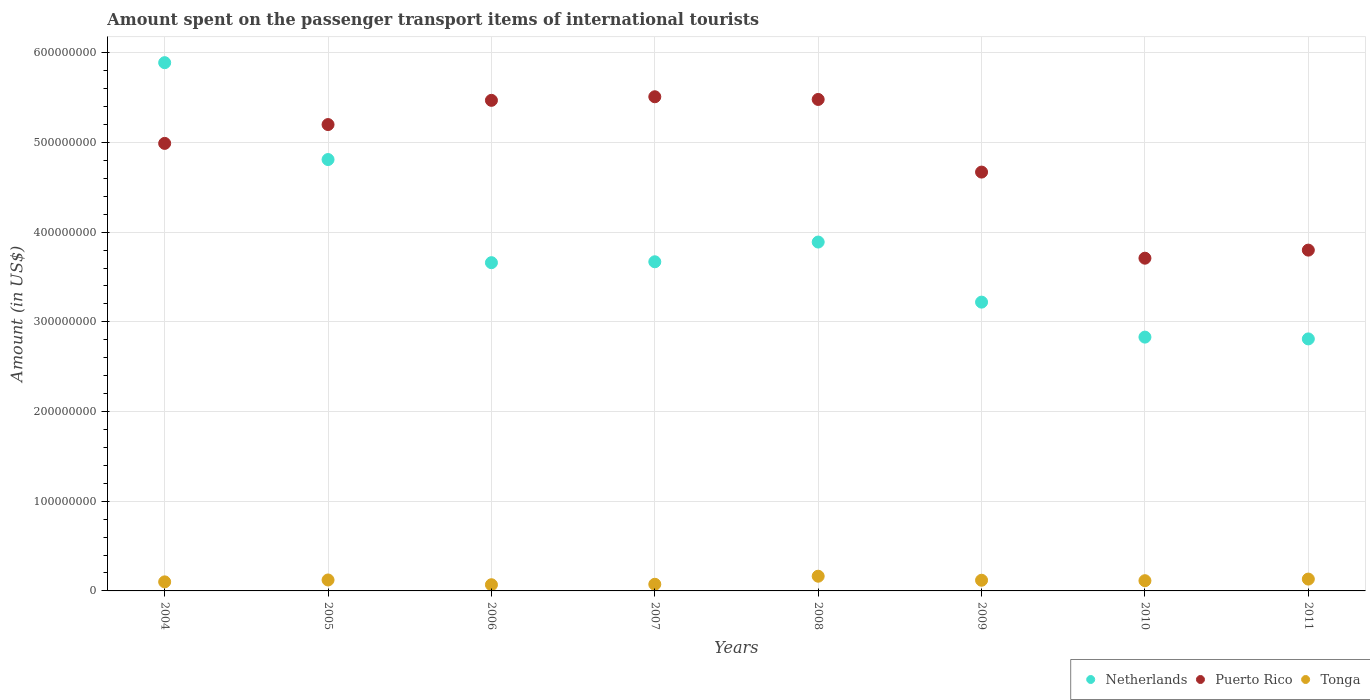How many different coloured dotlines are there?
Ensure brevity in your answer.  3. What is the amount spent on the passenger transport items of international tourists in Tonga in 2005?
Your answer should be compact. 1.22e+07. Across all years, what is the maximum amount spent on the passenger transport items of international tourists in Netherlands?
Make the answer very short. 5.89e+08. Across all years, what is the minimum amount spent on the passenger transport items of international tourists in Netherlands?
Keep it short and to the point. 2.81e+08. What is the total amount spent on the passenger transport items of international tourists in Puerto Rico in the graph?
Give a very brief answer. 3.88e+09. What is the difference between the amount spent on the passenger transport items of international tourists in Netherlands in 2004 and that in 2007?
Offer a very short reply. 2.22e+08. What is the difference between the amount spent on the passenger transport items of international tourists in Netherlands in 2005 and the amount spent on the passenger transport items of international tourists in Puerto Rico in 2010?
Give a very brief answer. 1.10e+08. What is the average amount spent on the passenger transport items of international tourists in Netherlands per year?
Keep it short and to the point. 3.85e+08. In the year 2008, what is the difference between the amount spent on the passenger transport items of international tourists in Puerto Rico and amount spent on the passenger transport items of international tourists in Netherlands?
Provide a short and direct response. 1.59e+08. What is the ratio of the amount spent on the passenger transport items of international tourists in Tonga in 2007 to that in 2009?
Offer a terse response. 0.62. Is the amount spent on the passenger transport items of international tourists in Puerto Rico in 2005 less than that in 2006?
Offer a very short reply. Yes. What is the difference between the highest and the second highest amount spent on the passenger transport items of international tourists in Tonga?
Provide a short and direct response. 3.20e+06. What is the difference between the highest and the lowest amount spent on the passenger transport items of international tourists in Puerto Rico?
Offer a terse response. 1.80e+08. In how many years, is the amount spent on the passenger transport items of international tourists in Tonga greater than the average amount spent on the passenger transport items of international tourists in Tonga taken over all years?
Offer a terse response. 5. Is it the case that in every year, the sum of the amount spent on the passenger transport items of international tourists in Tonga and amount spent on the passenger transport items of international tourists in Netherlands  is greater than the amount spent on the passenger transport items of international tourists in Puerto Rico?
Your answer should be very brief. No. How many dotlines are there?
Offer a terse response. 3. How many years are there in the graph?
Ensure brevity in your answer.  8. What is the difference between two consecutive major ticks on the Y-axis?
Provide a short and direct response. 1.00e+08. Does the graph contain any zero values?
Your answer should be compact. No. Does the graph contain grids?
Your answer should be compact. Yes. Where does the legend appear in the graph?
Keep it short and to the point. Bottom right. How are the legend labels stacked?
Make the answer very short. Horizontal. What is the title of the graph?
Give a very brief answer. Amount spent on the passenger transport items of international tourists. Does "Chad" appear as one of the legend labels in the graph?
Your answer should be compact. No. What is the Amount (in US$) in Netherlands in 2004?
Make the answer very short. 5.89e+08. What is the Amount (in US$) of Puerto Rico in 2004?
Provide a short and direct response. 4.99e+08. What is the Amount (in US$) in Tonga in 2004?
Your answer should be very brief. 1.01e+07. What is the Amount (in US$) in Netherlands in 2005?
Your response must be concise. 4.81e+08. What is the Amount (in US$) of Puerto Rico in 2005?
Provide a succinct answer. 5.20e+08. What is the Amount (in US$) of Tonga in 2005?
Give a very brief answer. 1.22e+07. What is the Amount (in US$) in Netherlands in 2006?
Ensure brevity in your answer.  3.66e+08. What is the Amount (in US$) of Puerto Rico in 2006?
Keep it short and to the point. 5.47e+08. What is the Amount (in US$) in Tonga in 2006?
Give a very brief answer. 6.90e+06. What is the Amount (in US$) in Netherlands in 2007?
Ensure brevity in your answer.  3.67e+08. What is the Amount (in US$) of Puerto Rico in 2007?
Keep it short and to the point. 5.51e+08. What is the Amount (in US$) in Tonga in 2007?
Offer a terse response. 7.40e+06. What is the Amount (in US$) in Netherlands in 2008?
Provide a succinct answer. 3.89e+08. What is the Amount (in US$) in Puerto Rico in 2008?
Keep it short and to the point. 5.48e+08. What is the Amount (in US$) of Tonga in 2008?
Offer a terse response. 1.64e+07. What is the Amount (in US$) of Netherlands in 2009?
Make the answer very short. 3.22e+08. What is the Amount (in US$) in Puerto Rico in 2009?
Your answer should be compact. 4.67e+08. What is the Amount (in US$) in Tonga in 2009?
Keep it short and to the point. 1.19e+07. What is the Amount (in US$) in Netherlands in 2010?
Your response must be concise. 2.83e+08. What is the Amount (in US$) of Puerto Rico in 2010?
Give a very brief answer. 3.71e+08. What is the Amount (in US$) of Tonga in 2010?
Keep it short and to the point. 1.14e+07. What is the Amount (in US$) of Netherlands in 2011?
Your response must be concise. 2.81e+08. What is the Amount (in US$) in Puerto Rico in 2011?
Your answer should be compact. 3.80e+08. What is the Amount (in US$) in Tonga in 2011?
Your answer should be compact. 1.32e+07. Across all years, what is the maximum Amount (in US$) in Netherlands?
Your answer should be compact. 5.89e+08. Across all years, what is the maximum Amount (in US$) in Puerto Rico?
Make the answer very short. 5.51e+08. Across all years, what is the maximum Amount (in US$) in Tonga?
Ensure brevity in your answer.  1.64e+07. Across all years, what is the minimum Amount (in US$) in Netherlands?
Your answer should be very brief. 2.81e+08. Across all years, what is the minimum Amount (in US$) in Puerto Rico?
Provide a short and direct response. 3.71e+08. Across all years, what is the minimum Amount (in US$) of Tonga?
Provide a short and direct response. 6.90e+06. What is the total Amount (in US$) of Netherlands in the graph?
Offer a terse response. 3.08e+09. What is the total Amount (in US$) of Puerto Rico in the graph?
Provide a short and direct response. 3.88e+09. What is the total Amount (in US$) of Tonga in the graph?
Provide a succinct answer. 8.95e+07. What is the difference between the Amount (in US$) in Netherlands in 2004 and that in 2005?
Give a very brief answer. 1.08e+08. What is the difference between the Amount (in US$) in Puerto Rico in 2004 and that in 2005?
Your answer should be very brief. -2.10e+07. What is the difference between the Amount (in US$) of Tonga in 2004 and that in 2005?
Your response must be concise. -2.10e+06. What is the difference between the Amount (in US$) in Netherlands in 2004 and that in 2006?
Make the answer very short. 2.23e+08. What is the difference between the Amount (in US$) in Puerto Rico in 2004 and that in 2006?
Ensure brevity in your answer.  -4.80e+07. What is the difference between the Amount (in US$) in Tonga in 2004 and that in 2006?
Make the answer very short. 3.20e+06. What is the difference between the Amount (in US$) of Netherlands in 2004 and that in 2007?
Ensure brevity in your answer.  2.22e+08. What is the difference between the Amount (in US$) of Puerto Rico in 2004 and that in 2007?
Provide a short and direct response. -5.20e+07. What is the difference between the Amount (in US$) of Tonga in 2004 and that in 2007?
Make the answer very short. 2.70e+06. What is the difference between the Amount (in US$) in Puerto Rico in 2004 and that in 2008?
Provide a short and direct response. -4.90e+07. What is the difference between the Amount (in US$) of Tonga in 2004 and that in 2008?
Give a very brief answer. -6.30e+06. What is the difference between the Amount (in US$) in Netherlands in 2004 and that in 2009?
Offer a terse response. 2.67e+08. What is the difference between the Amount (in US$) of Puerto Rico in 2004 and that in 2009?
Offer a terse response. 3.20e+07. What is the difference between the Amount (in US$) of Tonga in 2004 and that in 2009?
Keep it short and to the point. -1.80e+06. What is the difference between the Amount (in US$) of Netherlands in 2004 and that in 2010?
Your answer should be compact. 3.06e+08. What is the difference between the Amount (in US$) of Puerto Rico in 2004 and that in 2010?
Ensure brevity in your answer.  1.28e+08. What is the difference between the Amount (in US$) of Tonga in 2004 and that in 2010?
Give a very brief answer. -1.30e+06. What is the difference between the Amount (in US$) of Netherlands in 2004 and that in 2011?
Your response must be concise. 3.08e+08. What is the difference between the Amount (in US$) of Puerto Rico in 2004 and that in 2011?
Offer a very short reply. 1.19e+08. What is the difference between the Amount (in US$) of Tonga in 2004 and that in 2011?
Your answer should be very brief. -3.10e+06. What is the difference between the Amount (in US$) in Netherlands in 2005 and that in 2006?
Provide a succinct answer. 1.15e+08. What is the difference between the Amount (in US$) of Puerto Rico in 2005 and that in 2006?
Give a very brief answer. -2.70e+07. What is the difference between the Amount (in US$) of Tonga in 2005 and that in 2006?
Your answer should be compact. 5.30e+06. What is the difference between the Amount (in US$) in Netherlands in 2005 and that in 2007?
Your response must be concise. 1.14e+08. What is the difference between the Amount (in US$) of Puerto Rico in 2005 and that in 2007?
Keep it short and to the point. -3.10e+07. What is the difference between the Amount (in US$) in Tonga in 2005 and that in 2007?
Provide a succinct answer. 4.80e+06. What is the difference between the Amount (in US$) of Netherlands in 2005 and that in 2008?
Make the answer very short. 9.20e+07. What is the difference between the Amount (in US$) in Puerto Rico in 2005 and that in 2008?
Your answer should be compact. -2.80e+07. What is the difference between the Amount (in US$) in Tonga in 2005 and that in 2008?
Offer a very short reply. -4.20e+06. What is the difference between the Amount (in US$) of Netherlands in 2005 and that in 2009?
Give a very brief answer. 1.59e+08. What is the difference between the Amount (in US$) in Puerto Rico in 2005 and that in 2009?
Give a very brief answer. 5.30e+07. What is the difference between the Amount (in US$) in Tonga in 2005 and that in 2009?
Keep it short and to the point. 3.00e+05. What is the difference between the Amount (in US$) in Netherlands in 2005 and that in 2010?
Your response must be concise. 1.98e+08. What is the difference between the Amount (in US$) of Puerto Rico in 2005 and that in 2010?
Give a very brief answer. 1.49e+08. What is the difference between the Amount (in US$) in Tonga in 2005 and that in 2010?
Provide a short and direct response. 8.00e+05. What is the difference between the Amount (in US$) of Puerto Rico in 2005 and that in 2011?
Give a very brief answer. 1.40e+08. What is the difference between the Amount (in US$) of Netherlands in 2006 and that in 2007?
Provide a short and direct response. -1.00e+06. What is the difference between the Amount (in US$) in Puerto Rico in 2006 and that in 2007?
Your response must be concise. -4.00e+06. What is the difference between the Amount (in US$) in Tonga in 2006 and that in 2007?
Your answer should be very brief. -5.00e+05. What is the difference between the Amount (in US$) in Netherlands in 2006 and that in 2008?
Your answer should be very brief. -2.30e+07. What is the difference between the Amount (in US$) in Puerto Rico in 2006 and that in 2008?
Offer a terse response. -1.00e+06. What is the difference between the Amount (in US$) in Tonga in 2006 and that in 2008?
Give a very brief answer. -9.50e+06. What is the difference between the Amount (in US$) of Netherlands in 2006 and that in 2009?
Offer a very short reply. 4.40e+07. What is the difference between the Amount (in US$) of Puerto Rico in 2006 and that in 2009?
Make the answer very short. 8.00e+07. What is the difference between the Amount (in US$) in Tonga in 2006 and that in 2009?
Provide a short and direct response. -5.00e+06. What is the difference between the Amount (in US$) of Netherlands in 2006 and that in 2010?
Keep it short and to the point. 8.30e+07. What is the difference between the Amount (in US$) of Puerto Rico in 2006 and that in 2010?
Offer a very short reply. 1.76e+08. What is the difference between the Amount (in US$) of Tonga in 2006 and that in 2010?
Your answer should be compact. -4.50e+06. What is the difference between the Amount (in US$) of Netherlands in 2006 and that in 2011?
Your answer should be compact. 8.50e+07. What is the difference between the Amount (in US$) of Puerto Rico in 2006 and that in 2011?
Offer a very short reply. 1.67e+08. What is the difference between the Amount (in US$) of Tonga in 2006 and that in 2011?
Ensure brevity in your answer.  -6.30e+06. What is the difference between the Amount (in US$) in Netherlands in 2007 and that in 2008?
Provide a succinct answer. -2.20e+07. What is the difference between the Amount (in US$) in Puerto Rico in 2007 and that in 2008?
Your answer should be very brief. 3.00e+06. What is the difference between the Amount (in US$) of Tonga in 2007 and that in 2008?
Make the answer very short. -9.00e+06. What is the difference between the Amount (in US$) of Netherlands in 2007 and that in 2009?
Give a very brief answer. 4.50e+07. What is the difference between the Amount (in US$) of Puerto Rico in 2007 and that in 2009?
Offer a very short reply. 8.40e+07. What is the difference between the Amount (in US$) in Tonga in 2007 and that in 2009?
Keep it short and to the point. -4.50e+06. What is the difference between the Amount (in US$) of Netherlands in 2007 and that in 2010?
Give a very brief answer. 8.40e+07. What is the difference between the Amount (in US$) in Puerto Rico in 2007 and that in 2010?
Your answer should be very brief. 1.80e+08. What is the difference between the Amount (in US$) in Netherlands in 2007 and that in 2011?
Offer a very short reply. 8.60e+07. What is the difference between the Amount (in US$) in Puerto Rico in 2007 and that in 2011?
Your response must be concise. 1.71e+08. What is the difference between the Amount (in US$) of Tonga in 2007 and that in 2011?
Offer a very short reply. -5.80e+06. What is the difference between the Amount (in US$) of Netherlands in 2008 and that in 2009?
Provide a succinct answer. 6.70e+07. What is the difference between the Amount (in US$) of Puerto Rico in 2008 and that in 2009?
Your answer should be very brief. 8.10e+07. What is the difference between the Amount (in US$) in Tonga in 2008 and that in 2009?
Give a very brief answer. 4.50e+06. What is the difference between the Amount (in US$) of Netherlands in 2008 and that in 2010?
Provide a short and direct response. 1.06e+08. What is the difference between the Amount (in US$) of Puerto Rico in 2008 and that in 2010?
Your answer should be compact. 1.77e+08. What is the difference between the Amount (in US$) of Netherlands in 2008 and that in 2011?
Keep it short and to the point. 1.08e+08. What is the difference between the Amount (in US$) of Puerto Rico in 2008 and that in 2011?
Your answer should be compact. 1.68e+08. What is the difference between the Amount (in US$) in Tonga in 2008 and that in 2011?
Offer a terse response. 3.20e+06. What is the difference between the Amount (in US$) of Netherlands in 2009 and that in 2010?
Make the answer very short. 3.90e+07. What is the difference between the Amount (in US$) in Puerto Rico in 2009 and that in 2010?
Provide a succinct answer. 9.60e+07. What is the difference between the Amount (in US$) in Netherlands in 2009 and that in 2011?
Provide a short and direct response. 4.10e+07. What is the difference between the Amount (in US$) of Puerto Rico in 2009 and that in 2011?
Your answer should be compact. 8.70e+07. What is the difference between the Amount (in US$) in Tonga in 2009 and that in 2011?
Your response must be concise. -1.30e+06. What is the difference between the Amount (in US$) of Puerto Rico in 2010 and that in 2011?
Offer a very short reply. -9.00e+06. What is the difference between the Amount (in US$) of Tonga in 2010 and that in 2011?
Provide a short and direct response. -1.80e+06. What is the difference between the Amount (in US$) of Netherlands in 2004 and the Amount (in US$) of Puerto Rico in 2005?
Offer a very short reply. 6.90e+07. What is the difference between the Amount (in US$) in Netherlands in 2004 and the Amount (in US$) in Tonga in 2005?
Your response must be concise. 5.77e+08. What is the difference between the Amount (in US$) in Puerto Rico in 2004 and the Amount (in US$) in Tonga in 2005?
Ensure brevity in your answer.  4.87e+08. What is the difference between the Amount (in US$) of Netherlands in 2004 and the Amount (in US$) of Puerto Rico in 2006?
Your answer should be very brief. 4.20e+07. What is the difference between the Amount (in US$) in Netherlands in 2004 and the Amount (in US$) in Tonga in 2006?
Your answer should be compact. 5.82e+08. What is the difference between the Amount (in US$) of Puerto Rico in 2004 and the Amount (in US$) of Tonga in 2006?
Give a very brief answer. 4.92e+08. What is the difference between the Amount (in US$) in Netherlands in 2004 and the Amount (in US$) in Puerto Rico in 2007?
Offer a terse response. 3.80e+07. What is the difference between the Amount (in US$) in Netherlands in 2004 and the Amount (in US$) in Tonga in 2007?
Your response must be concise. 5.82e+08. What is the difference between the Amount (in US$) of Puerto Rico in 2004 and the Amount (in US$) of Tonga in 2007?
Provide a short and direct response. 4.92e+08. What is the difference between the Amount (in US$) of Netherlands in 2004 and the Amount (in US$) of Puerto Rico in 2008?
Keep it short and to the point. 4.10e+07. What is the difference between the Amount (in US$) of Netherlands in 2004 and the Amount (in US$) of Tonga in 2008?
Your response must be concise. 5.73e+08. What is the difference between the Amount (in US$) of Puerto Rico in 2004 and the Amount (in US$) of Tonga in 2008?
Provide a succinct answer. 4.83e+08. What is the difference between the Amount (in US$) in Netherlands in 2004 and the Amount (in US$) in Puerto Rico in 2009?
Keep it short and to the point. 1.22e+08. What is the difference between the Amount (in US$) in Netherlands in 2004 and the Amount (in US$) in Tonga in 2009?
Your answer should be very brief. 5.77e+08. What is the difference between the Amount (in US$) in Puerto Rico in 2004 and the Amount (in US$) in Tonga in 2009?
Keep it short and to the point. 4.87e+08. What is the difference between the Amount (in US$) in Netherlands in 2004 and the Amount (in US$) in Puerto Rico in 2010?
Give a very brief answer. 2.18e+08. What is the difference between the Amount (in US$) of Netherlands in 2004 and the Amount (in US$) of Tonga in 2010?
Your answer should be compact. 5.78e+08. What is the difference between the Amount (in US$) in Puerto Rico in 2004 and the Amount (in US$) in Tonga in 2010?
Offer a terse response. 4.88e+08. What is the difference between the Amount (in US$) of Netherlands in 2004 and the Amount (in US$) of Puerto Rico in 2011?
Give a very brief answer. 2.09e+08. What is the difference between the Amount (in US$) of Netherlands in 2004 and the Amount (in US$) of Tonga in 2011?
Provide a succinct answer. 5.76e+08. What is the difference between the Amount (in US$) in Puerto Rico in 2004 and the Amount (in US$) in Tonga in 2011?
Offer a very short reply. 4.86e+08. What is the difference between the Amount (in US$) of Netherlands in 2005 and the Amount (in US$) of Puerto Rico in 2006?
Keep it short and to the point. -6.60e+07. What is the difference between the Amount (in US$) of Netherlands in 2005 and the Amount (in US$) of Tonga in 2006?
Provide a succinct answer. 4.74e+08. What is the difference between the Amount (in US$) in Puerto Rico in 2005 and the Amount (in US$) in Tonga in 2006?
Provide a succinct answer. 5.13e+08. What is the difference between the Amount (in US$) of Netherlands in 2005 and the Amount (in US$) of Puerto Rico in 2007?
Provide a short and direct response. -7.00e+07. What is the difference between the Amount (in US$) of Netherlands in 2005 and the Amount (in US$) of Tonga in 2007?
Give a very brief answer. 4.74e+08. What is the difference between the Amount (in US$) in Puerto Rico in 2005 and the Amount (in US$) in Tonga in 2007?
Give a very brief answer. 5.13e+08. What is the difference between the Amount (in US$) of Netherlands in 2005 and the Amount (in US$) of Puerto Rico in 2008?
Make the answer very short. -6.70e+07. What is the difference between the Amount (in US$) in Netherlands in 2005 and the Amount (in US$) in Tonga in 2008?
Your answer should be very brief. 4.65e+08. What is the difference between the Amount (in US$) in Puerto Rico in 2005 and the Amount (in US$) in Tonga in 2008?
Give a very brief answer. 5.04e+08. What is the difference between the Amount (in US$) in Netherlands in 2005 and the Amount (in US$) in Puerto Rico in 2009?
Make the answer very short. 1.40e+07. What is the difference between the Amount (in US$) in Netherlands in 2005 and the Amount (in US$) in Tonga in 2009?
Your response must be concise. 4.69e+08. What is the difference between the Amount (in US$) of Puerto Rico in 2005 and the Amount (in US$) of Tonga in 2009?
Your response must be concise. 5.08e+08. What is the difference between the Amount (in US$) in Netherlands in 2005 and the Amount (in US$) in Puerto Rico in 2010?
Ensure brevity in your answer.  1.10e+08. What is the difference between the Amount (in US$) of Netherlands in 2005 and the Amount (in US$) of Tonga in 2010?
Offer a very short reply. 4.70e+08. What is the difference between the Amount (in US$) of Puerto Rico in 2005 and the Amount (in US$) of Tonga in 2010?
Keep it short and to the point. 5.09e+08. What is the difference between the Amount (in US$) of Netherlands in 2005 and the Amount (in US$) of Puerto Rico in 2011?
Provide a succinct answer. 1.01e+08. What is the difference between the Amount (in US$) in Netherlands in 2005 and the Amount (in US$) in Tonga in 2011?
Ensure brevity in your answer.  4.68e+08. What is the difference between the Amount (in US$) in Puerto Rico in 2005 and the Amount (in US$) in Tonga in 2011?
Your answer should be very brief. 5.07e+08. What is the difference between the Amount (in US$) of Netherlands in 2006 and the Amount (in US$) of Puerto Rico in 2007?
Ensure brevity in your answer.  -1.85e+08. What is the difference between the Amount (in US$) of Netherlands in 2006 and the Amount (in US$) of Tonga in 2007?
Your response must be concise. 3.59e+08. What is the difference between the Amount (in US$) of Puerto Rico in 2006 and the Amount (in US$) of Tonga in 2007?
Your answer should be compact. 5.40e+08. What is the difference between the Amount (in US$) of Netherlands in 2006 and the Amount (in US$) of Puerto Rico in 2008?
Provide a succinct answer. -1.82e+08. What is the difference between the Amount (in US$) of Netherlands in 2006 and the Amount (in US$) of Tonga in 2008?
Provide a succinct answer. 3.50e+08. What is the difference between the Amount (in US$) of Puerto Rico in 2006 and the Amount (in US$) of Tonga in 2008?
Provide a short and direct response. 5.31e+08. What is the difference between the Amount (in US$) in Netherlands in 2006 and the Amount (in US$) in Puerto Rico in 2009?
Ensure brevity in your answer.  -1.01e+08. What is the difference between the Amount (in US$) in Netherlands in 2006 and the Amount (in US$) in Tonga in 2009?
Your answer should be compact. 3.54e+08. What is the difference between the Amount (in US$) of Puerto Rico in 2006 and the Amount (in US$) of Tonga in 2009?
Your answer should be compact. 5.35e+08. What is the difference between the Amount (in US$) of Netherlands in 2006 and the Amount (in US$) of Puerto Rico in 2010?
Give a very brief answer. -5.00e+06. What is the difference between the Amount (in US$) in Netherlands in 2006 and the Amount (in US$) in Tonga in 2010?
Give a very brief answer. 3.55e+08. What is the difference between the Amount (in US$) in Puerto Rico in 2006 and the Amount (in US$) in Tonga in 2010?
Offer a terse response. 5.36e+08. What is the difference between the Amount (in US$) of Netherlands in 2006 and the Amount (in US$) of Puerto Rico in 2011?
Ensure brevity in your answer.  -1.40e+07. What is the difference between the Amount (in US$) of Netherlands in 2006 and the Amount (in US$) of Tonga in 2011?
Offer a terse response. 3.53e+08. What is the difference between the Amount (in US$) in Puerto Rico in 2006 and the Amount (in US$) in Tonga in 2011?
Offer a very short reply. 5.34e+08. What is the difference between the Amount (in US$) in Netherlands in 2007 and the Amount (in US$) in Puerto Rico in 2008?
Your answer should be very brief. -1.81e+08. What is the difference between the Amount (in US$) in Netherlands in 2007 and the Amount (in US$) in Tonga in 2008?
Your answer should be very brief. 3.51e+08. What is the difference between the Amount (in US$) in Puerto Rico in 2007 and the Amount (in US$) in Tonga in 2008?
Provide a short and direct response. 5.35e+08. What is the difference between the Amount (in US$) of Netherlands in 2007 and the Amount (in US$) of Puerto Rico in 2009?
Give a very brief answer. -1.00e+08. What is the difference between the Amount (in US$) in Netherlands in 2007 and the Amount (in US$) in Tonga in 2009?
Make the answer very short. 3.55e+08. What is the difference between the Amount (in US$) in Puerto Rico in 2007 and the Amount (in US$) in Tonga in 2009?
Your answer should be compact. 5.39e+08. What is the difference between the Amount (in US$) of Netherlands in 2007 and the Amount (in US$) of Puerto Rico in 2010?
Your answer should be very brief. -4.00e+06. What is the difference between the Amount (in US$) of Netherlands in 2007 and the Amount (in US$) of Tonga in 2010?
Offer a terse response. 3.56e+08. What is the difference between the Amount (in US$) in Puerto Rico in 2007 and the Amount (in US$) in Tonga in 2010?
Offer a terse response. 5.40e+08. What is the difference between the Amount (in US$) of Netherlands in 2007 and the Amount (in US$) of Puerto Rico in 2011?
Offer a terse response. -1.30e+07. What is the difference between the Amount (in US$) in Netherlands in 2007 and the Amount (in US$) in Tonga in 2011?
Give a very brief answer. 3.54e+08. What is the difference between the Amount (in US$) of Puerto Rico in 2007 and the Amount (in US$) of Tonga in 2011?
Provide a succinct answer. 5.38e+08. What is the difference between the Amount (in US$) in Netherlands in 2008 and the Amount (in US$) in Puerto Rico in 2009?
Offer a very short reply. -7.80e+07. What is the difference between the Amount (in US$) of Netherlands in 2008 and the Amount (in US$) of Tonga in 2009?
Offer a terse response. 3.77e+08. What is the difference between the Amount (in US$) of Puerto Rico in 2008 and the Amount (in US$) of Tonga in 2009?
Give a very brief answer. 5.36e+08. What is the difference between the Amount (in US$) of Netherlands in 2008 and the Amount (in US$) of Puerto Rico in 2010?
Offer a very short reply. 1.80e+07. What is the difference between the Amount (in US$) of Netherlands in 2008 and the Amount (in US$) of Tonga in 2010?
Make the answer very short. 3.78e+08. What is the difference between the Amount (in US$) of Puerto Rico in 2008 and the Amount (in US$) of Tonga in 2010?
Give a very brief answer. 5.37e+08. What is the difference between the Amount (in US$) of Netherlands in 2008 and the Amount (in US$) of Puerto Rico in 2011?
Offer a terse response. 9.00e+06. What is the difference between the Amount (in US$) in Netherlands in 2008 and the Amount (in US$) in Tonga in 2011?
Your response must be concise. 3.76e+08. What is the difference between the Amount (in US$) in Puerto Rico in 2008 and the Amount (in US$) in Tonga in 2011?
Ensure brevity in your answer.  5.35e+08. What is the difference between the Amount (in US$) in Netherlands in 2009 and the Amount (in US$) in Puerto Rico in 2010?
Offer a very short reply. -4.90e+07. What is the difference between the Amount (in US$) in Netherlands in 2009 and the Amount (in US$) in Tonga in 2010?
Your answer should be very brief. 3.11e+08. What is the difference between the Amount (in US$) of Puerto Rico in 2009 and the Amount (in US$) of Tonga in 2010?
Provide a succinct answer. 4.56e+08. What is the difference between the Amount (in US$) of Netherlands in 2009 and the Amount (in US$) of Puerto Rico in 2011?
Make the answer very short. -5.80e+07. What is the difference between the Amount (in US$) of Netherlands in 2009 and the Amount (in US$) of Tonga in 2011?
Your answer should be compact. 3.09e+08. What is the difference between the Amount (in US$) of Puerto Rico in 2009 and the Amount (in US$) of Tonga in 2011?
Your response must be concise. 4.54e+08. What is the difference between the Amount (in US$) in Netherlands in 2010 and the Amount (in US$) in Puerto Rico in 2011?
Give a very brief answer. -9.70e+07. What is the difference between the Amount (in US$) in Netherlands in 2010 and the Amount (in US$) in Tonga in 2011?
Offer a terse response. 2.70e+08. What is the difference between the Amount (in US$) in Puerto Rico in 2010 and the Amount (in US$) in Tonga in 2011?
Give a very brief answer. 3.58e+08. What is the average Amount (in US$) of Netherlands per year?
Your answer should be very brief. 3.85e+08. What is the average Amount (in US$) in Puerto Rico per year?
Provide a short and direct response. 4.85e+08. What is the average Amount (in US$) of Tonga per year?
Offer a terse response. 1.12e+07. In the year 2004, what is the difference between the Amount (in US$) of Netherlands and Amount (in US$) of Puerto Rico?
Provide a succinct answer. 9.00e+07. In the year 2004, what is the difference between the Amount (in US$) of Netherlands and Amount (in US$) of Tonga?
Give a very brief answer. 5.79e+08. In the year 2004, what is the difference between the Amount (in US$) in Puerto Rico and Amount (in US$) in Tonga?
Ensure brevity in your answer.  4.89e+08. In the year 2005, what is the difference between the Amount (in US$) of Netherlands and Amount (in US$) of Puerto Rico?
Keep it short and to the point. -3.90e+07. In the year 2005, what is the difference between the Amount (in US$) of Netherlands and Amount (in US$) of Tonga?
Ensure brevity in your answer.  4.69e+08. In the year 2005, what is the difference between the Amount (in US$) of Puerto Rico and Amount (in US$) of Tonga?
Keep it short and to the point. 5.08e+08. In the year 2006, what is the difference between the Amount (in US$) of Netherlands and Amount (in US$) of Puerto Rico?
Your answer should be very brief. -1.81e+08. In the year 2006, what is the difference between the Amount (in US$) of Netherlands and Amount (in US$) of Tonga?
Ensure brevity in your answer.  3.59e+08. In the year 2006, what is the difference between the Amount (in US$) of Puerto Rico and Amount (in US$) of Tonga?
Ensure brevity in your answer.  5.40e+08. In the year 2007, what is the difference between the Amount (in US$) in Netherlands and Amount (in US$) in Puerto Rico?
Provide a short and direct response. -1.84e+08. In the year 2007, what is the difference between the Amount (in US$) of Netherlands and Amount (in US$) of Tonga?
Offer a very short reply. 3.60e+08. In the year 2007, what is the difference between the Amount (in US$) in Puerto Rico and Amount (in US$) in Tonga?
Keep it short and to the point. 5.44e+08. In the year 2008, what is the difference between the Amount (in US$) of Netherlands and Amount (in US$) of Puerto Rico?
Offer a terse response. -1.59e+08. In the year 2008, what is the difference between the Amount (in US$) of Netherlands and Amount (in US$) of Tonga?
Keep it short and to the point. 3.73e+08. In the year 2008, what is the difference between the Amount (in US$) of Puerto Rico and Amount (in US$) of Tonga?
Your answer should be compact. 5.32e+08. In the year 2009, what is the difference between the Amount (in US$) of Netherlands and Amount (in US$) of Puerto Rico?
Ensure brevity in your answer.  -1.45e+08. In the year 2009, what is the difference between the Amount (in US$) of Netherlands and Amount (in US$) of Tonga?
Your answer should be compact. 3.10e+08. In the year 2009, what is the difference between the Amount (in US$) of Puerto Rico and Amount (in US$) of Tonga?
Your response must be concise. 4.55e+08. In the year 2010, what is the difference between the Amount (in US$) of Netherlands and Amount (in US$) of Puerto Rico?
Your answer should be compact. -8.80e+07. In the year 2010, what is the difference between the Amount (in US$) of Netherlands and Amount (in US$) of Tonga?
Offer a terse response. 2.72e+08. In the year 2010, what is the difference between the Amount (in US$) of Puerto Rico and Amount (in US$) of Tonga?
Give a very brief answer. 3.60e+08. In the year 2011, what is the difference between the Amount (in US$) of Netherlands and Amount (in US$) of Puerto Rico?
Offer a very short reply. -9.90e+07. In the year 2011, what is the difference between the Amount (in US$) of Netherlands and Amount (in US$) of Tonga?
Offer a very short reply. 2.68e+08. In the year 2011, what is the difference between the Amount (in US$) of Puerto Rico and Amount (in US$) of Tonga?
Give a very brief answer. 3.67e+08. What is the ratio of the Amount (in US$) of Netherlands in 2004 to that in 2005?
Provide a succinct answer. 1.22. What is the ratio of the Amount (in US$) of Puerto Rico in 2004 to that in 2005?
Provide a short and direct response. 0.96. What is the ratio of the Amount (in US$) of Tonga in 2004 to that in 2005?
Give a very brief answer. 0.83. What is the ratio of the Amount (in US$) in Netherlands in 2004 to that in 2006?
Keep it short and to the point. 1.61. What is the ratio of the Amount (in US$) in Puerto Rico in 2004 to that in 2006?
Your answer should be compact. 0.91. What is the ratio of the Amount (in US$) of Tonga in 2004 to that in 2006?
Make the answer very short. 1.46. What is the ratio of the Amount (in US$) of Netherlands in 2004 to that in 2007?
Provide a short and direct response. 1.6. What is the ratio of the Amount (in US$) of Puerto Rico in 2004 to that in 2007?
Your response must be concise. 0.91. What is the ratio of the Amount (in US$) of Tonga in 2004 to that in 2007?
Your answer should be very brief. 1.36. What is the ratio of the Amount (in US$) of Netherlands in 2004 to that in 2008?
Offer a terse response. 1.51. What is the ratio of the Amount (in US$) in Puerto Rico in 2004 to that in 2008?
Your answer should be very brief. 0.91. What is the ratio of the Amount (in US$) in Tonga in 2004 to that in 2008?
Offer a very short reply. 0.62. What is the ratio of the Amount (in US$) of Netherlands in 2004 to that in 2009?
Your answer should be very brief. 1.83. What is the ratio of the Amount (in US$) of Puerto Rico in 2004 to that in 2009?
Ensure brevity in your answer.  1.07. What is the ratio of the Amount (in US$) of Tonga in 2004 to that in 2009?
Offer a very short reply. 0.85. What is the ratio of the Amount (in US$) of Netherlands in 2004 to that in 2010?
Offer a terse response. 2.08. What is the ratio of the Amount (in US$) of Puerto Rico in 2004 to that in 2010?
Ensure brevity in your answer.  1.34. What is the ratio of the Amount (in US$) in Tonga in 2004 to that in 2010?
Give a very brief answer. 0.89. What is the ratio of the Amount (in US$) in Netherlands in 2004 to that in 2011?
Provide a succinct answer. 2.1. What is the ratio of the Amount (in US$) in Puerto Rico in 2004 to that in 2011?
Make the answer very short. 1.31. What is the ratio of the Amount (in US$) of Tonga in 2004 to that in 2011?
Provide a short and direct response. 0.77. What is the ratio of the Amount (in US$) in Netherlands in 2005 to that in 2006?
Offer a terse response. 1.31. What is the ratio of the Amount (in US$) of Puerto Rico in 2005 to that in 2006?
Provide a succinct answer. 0.95. What is the ratio of the Amount (in US$) in Tonga in 2005 to that in 2006?
Provide a succinct answer. 1.77. What is the ratio of the Amount (in US$) in Netherlands in 2005 to that in 2007?
Your response must be concise. 1.31. What is the ratio of the Amount (in US$) of Puerto Rico in 2005 to that in 2007?
Your answer should be very brief. 0.94. What is the ratio of the Amount (in US$) of Tonga in 2005 to that in 2007?
Make the answer very short. 1.65. What is the ratio of the Amount (in US$) of Netherlands in 2005 to that in 2008?
Ensure brevity in your answer.  1.24. What is the ratio of the Amount (in US$) in Puerto Rico in 2005 to that in 2008?
Provide a succinct answer. 0.95. What is the ratio of the Amount (in US$) of Tonga in 2005 to that in 2008?
Offer a very short reply. 0.74. What is the ratio of the Amount (in US$) in Netherlands in 2005 to that in 2009?
Provide a succinct answer. 1.49. What is the ratio of the Amount (in US$) in Puerto Rico in 2005 to that in 2009?
Make the answer very short. 1.11. What is the ratio of the Amount (in US$) of Tonga in 2005 to that in 2009?
Ensure brevity in your answer.  1.03. What is the ratio of the Amount (in US$) of Netherlands in 2005 to that in 2010?
Ensure brevity in your answer.  1.7. What is the ratio of the Amount (in US$) of Puerto Rico in 2005 to that in 2010?
Provide a short and direct response. 1.4. What is the ratio of the Amount (in US$) of Tonga in 2005 to that in 2010?
Provide a short and direct response. 1.07. What is the ratio of the Amount (in US$) of Netherlands in 2005 to that in 2011?
Offer a very short reply. 1.71. What is the ratio of the Amount (in US$) of Puerto Rico in 2005 to that in 2011?
Give a very brief answer. 1.37. What is the ratio of the Amount (in US$) of Tonga in 2005 to that in 2011?
Your answer should be very brief. 0.92. What is the ratio of the Amount (in US$) in Tonga in 2006 to that in 2007?
Your answer should be very brief. 0.93. What is the ratio of the Amount (in US$) in Netherlands in 2006 to that in 2008?
Your response must be concise. 0.94. What is the ratio of the Amount (in US$) in Puerto Rico in 2006 to that in 2008?
Your answer should be compact. 1. What is the ratio of the Amount (in US$) in Tonga in 2006 to that in 2008?
Your answer should be compact. 0.42. What is the ratio of the Amount (in US$) of Netherlands in 2006 to that in 2009?
Offer a terse response. 1.14. What is the ratio of the Amount (in US$) in Puerto Rico in 2006 to that in 2009?
Provide a succinct answer. 1.17. What is the ratio of the Amount (in US$) in Tonga in 2006 to that in 2009?
Ensure brevity in your answer.  0.58. What is the ratio of the Amount (in US$) of Netherlands in 2006 to that in 2010?
Make the answer very short. 1.29. What is the ratio of the Amount (in US$) in Puerto Rico in 2006 to that in 2010?
Keep it short and to the point. 1.47. What is the ratio of the Amount (in US$) in Tonga in 2006 to that in 2010?
Offer a very short reply. 0.61. What is the ratio of the Amount (in US$) of Netherlands in 2006 to that in 2011?
Your answer should be very brief. 1.3. What is the ratio of the Amount (in US$) in Puerto Rico in 2006 to that in 2011?
Offer a terse response. 1.44. What is the ratio of the Amount (in US$) in Tonga in 2006 to that in 2011?
Make the answer very short. 0.52. What is the ratio of the Amount (in US$) of Netherlands in 2007 to that in 2008?
Keep it short and to the point. 0.94. What is the ratio of the Amount (in US$) in Tonga in 2007 to that in 2008?
Your response must be concise. 0.45. What is the ratio of the Amount (in US$) in Netherlands in 2007 to that in 2009?
Your answer should be very brief. 1.14. What is the ratio of the Amount (in US$) in Puerto Rico in 2007 to that in 2009?
Make the answer very short. 1.18. What is the ratio of the Amount (in US$) in Tonga in 2007 to that in 2009?
Offer a terse response. 0.62. What is the ratio of the Amount (in US$) of Netherlands in 2007 to that in 2010?
Provide a short and direct response. 1.3. What is the ratio of the Amount (in US$) in Puerto Rico in 2007 to that in 2010?
Provide a short and direct response. 1.49. What is the ratio of the Amount (in US$) of Tonga in 2007 to that in 2010?
Offer a very short reply. 0.65. What is the ratio of the Amount (in US$) in Netherlands in 2007 to that in 2011?
Offer a very short reply. 1.31. What is the ratio of the Amount (in US$) in Puerto Rico in 2007 to that in 2011?
Make the answer very short. 1.45. What is the ratio of the Amount (in US$) in Tonga in 2007 to that in 2011?
Your answer should be very brief. 0.56. What is the ratio of the Amount (in US$) of Netherlands in 2008 to that in 2009?
Give a very brief answer. 1.21. What is the ratio of the Amount (in US$) in Puerto Rico in 2008 to that in 2009?
Your answer should be very brief. 1.17. What is the ratio of the Amount (in US$) in Tonga in 2008 to that in 2009?
Keep it short and to the point. 1.38. What is the ratio of the Amount (in US$) in Netherlands in 2008 to that in 2010?
Provide a short and direct response. 1.37. What is the ratio of the Amount (in US$) of Puerto Rico in 2008 to that in 2010?
Offer a terse response. 1.48. What is the ratio of the Amount (in US$) in Tonga in 2008 to that in 2010?
Your answer should be compact. 1.44. What is the ratio of the Amount (in US$) in Netherlands in 2008 to that in 2011?
Your answer should be very brief. 1.38. What is the ratio of the Amount (in US$) in Puerto Rico in 2008 to that in 2011?
Ensure brevity in your answer.  1.44. What is the ratio of the Amount (in US$) in Tonga in 2008 to that in 2011?
Ensure brevity in your answer.  1.24. What is the ratio of the Amount (in US$) in Netherlands in 2009 to that in 2010?
Ensure brevity in your answer.  1.14. What is the ratio of the Amount (in US$) of Puerto Rico in 2009 to that in 2010?
Keep it short and to the point. 1.26. What is the ratio of the Amount (in US$) of Tonga in 2009 to that in 2010?
Ensure brevity in your answer.  1.04. What is the ratio of the Amount (in US$) of Netherlands in 2009 to that in 2011?
Provide a short and direct response. 1.15. What is the ratio of the Amount (in US$) in Puerto Rico in 2009 to that in 2011?
Make the answer very short. 1.23. What is the ratio of the Amount (in US$) in Tonga in 2009 to that in 2011?
Your response must be concise. 0.9. What is the ratio of the Amount (in US$) in Netherlands in 2010 to that in 2011?
Your answer should be compact. 1.01. What is the ratio of the Amount (in US$) in Puerto Rico in 2010 to that in 2011?
Offer a terse response. 0.98. What is the ratio of the Amount (in US$) in Tonga in 2010 to that in 2011?
Your answer should be very brief. 0.86. What is the difference between the highest and the second highest Amount (in US$) of Netherlands?
Your answer should be very brief. 1.08e+08. What is the difference between the highest and the second highest Amount (in US$) of Tonga?
Your response must be concise. 3.20e+06. What is the difference between the highest and the lowest Amount (in US$) in Netherlands?
Offer a terse response. 3.08e+08. What is the difference between the highest and the lowest Amount (in US$) in Puerto Rico?
Your response must be concise. 1.80e+08. What is the difference between the highest and the lowest Amount (in US$) of Tonga?
Your response must be concise. 9.50e+06. 